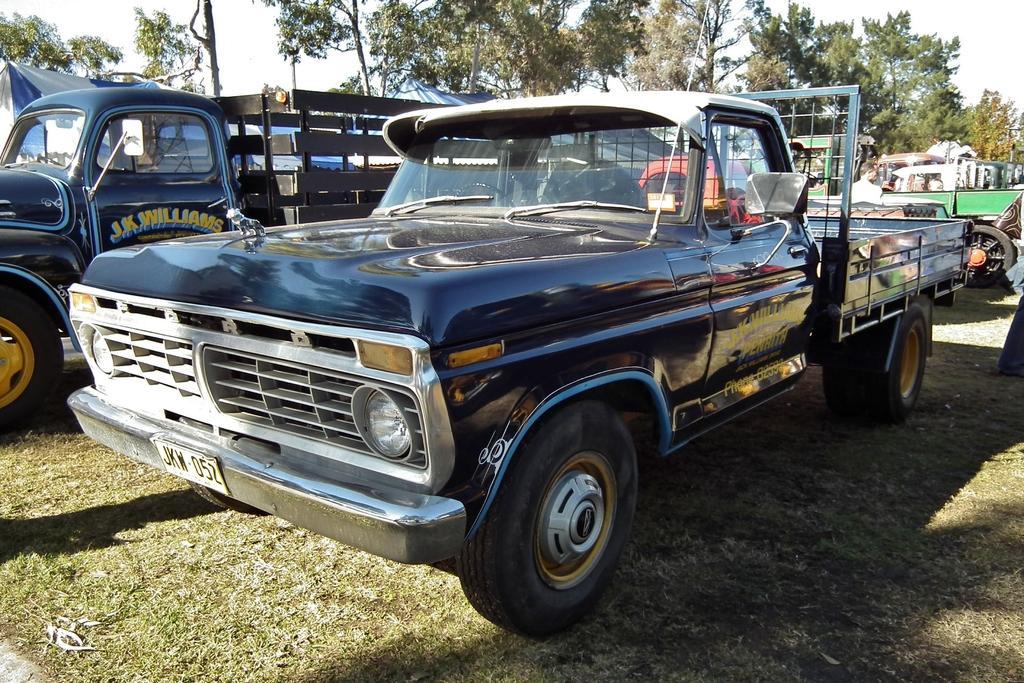In one or two sentences, can you explain what this image depicts? This image is taken outdoors. At the bottom of the image there is a ground with grass on it. In the background there are many trees. In the middle of the image a few vehicles are parked on the ground and there are two tents. 